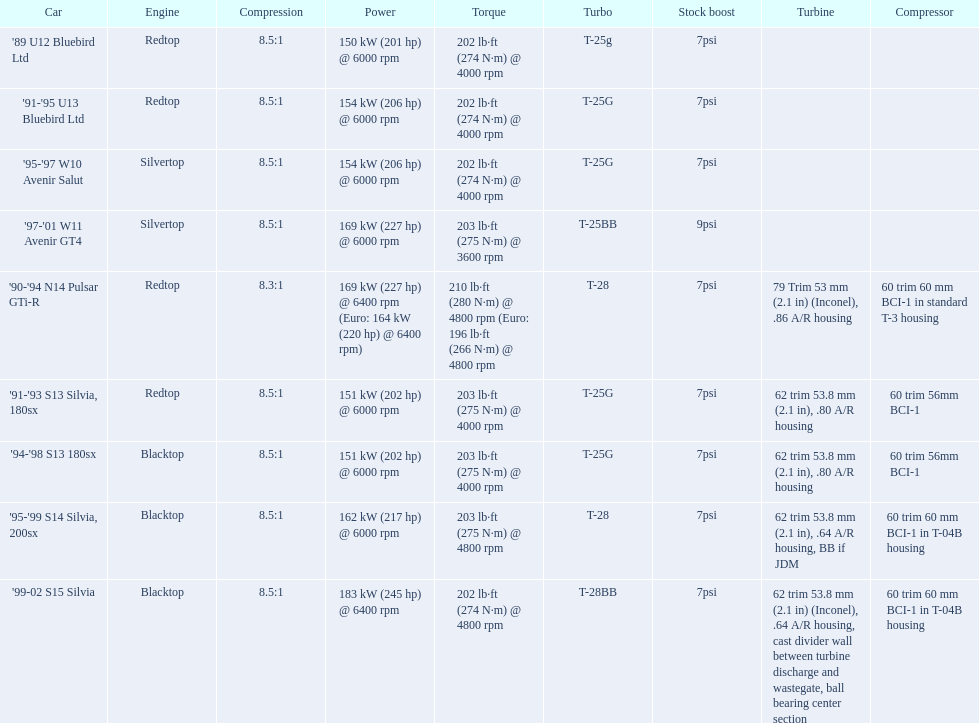What are all the nissan automobile models? '89 U12 Bluebird Ltd, '91-'95 U13 Bluebird Ltd, '95-'97 W10 Avenir Salut, '97-'01 W11 Avenir GT4, '90-'94 N14 Pulsar GTi-R, '91-'93 S13 Silvia, 180sx, '94-'98 S13 180sx, '95-'99 S14 Silvia, 200sx, '99-02 S15 Silvia. From these models, which one is a '90-'94 n14 pulsar gti-r? '90-'94 N14 Pulsar GTi-R. What is the compression of this automobile? 8.3:1. 